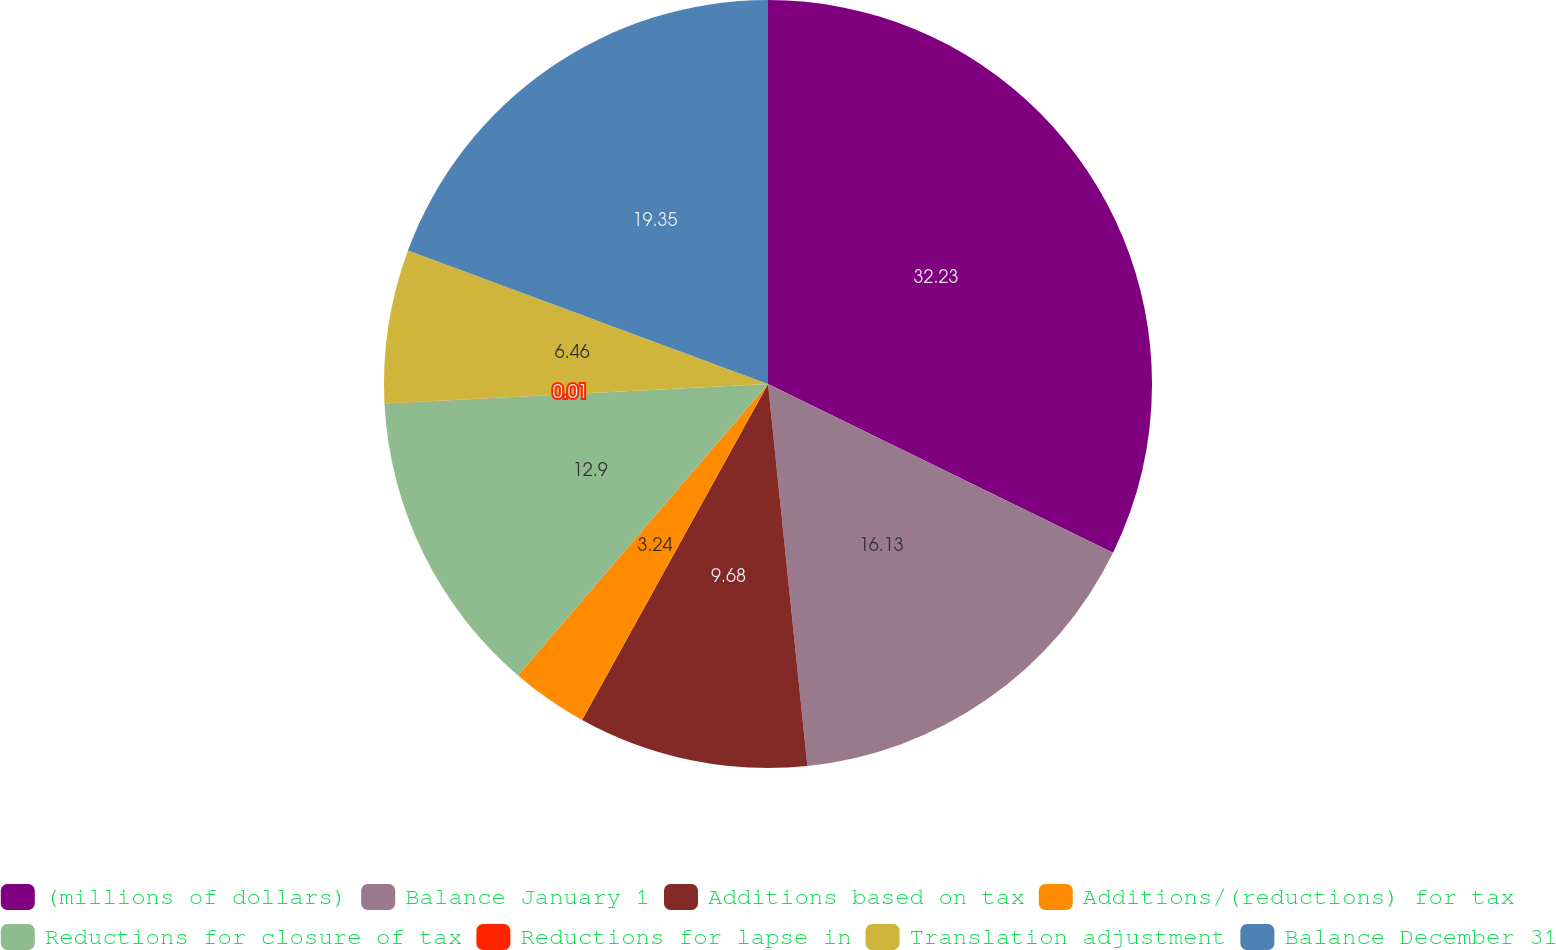Convert chart. <chart><loc_0><loc_0><loc_500><loc_500><pie_chart><fcel>(millions of dollars)<fcel>Balance January 1<fcel>Additions based on tax<fcel>Additions/(reductions) for tax<fcel>Reductions for closure of tax<fcel>Reductions for lapse in<fcel>Translation adjustment<fcel>Balance December 31<nl><fcel>32.24%<fcel>16.13%<fcel>9.68%<fcel>3.24%<fcel>12.9%<fcel>0.01%<fcel>6.46%<fcel>19.35%<nl></chart> 